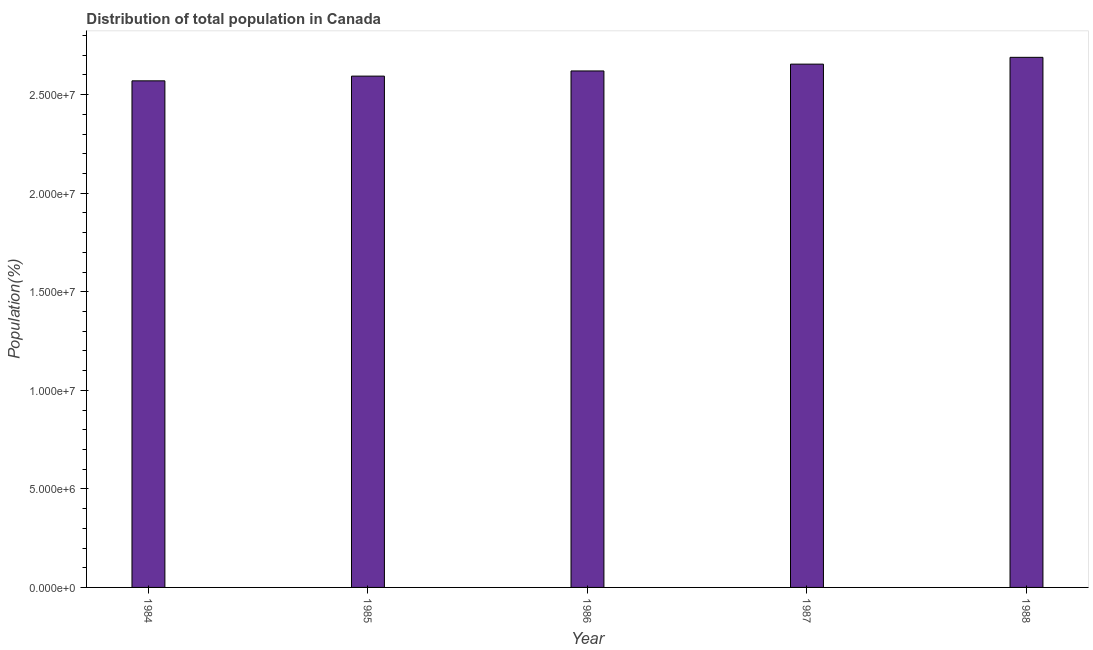Does the graph contain any zero values?
Provide a short and direct response. No. What is the title of the graph?
Your answer should be compact. Distribution of total population in Canada . What is the label or title of the Y-axis?
Give a very brief answer. Population(%). What is the population in 1987?
Provide a succinct answer. 2.66e+07. Across all years, what is the maximum population?
Your answer should be compact. 2.69e+07. Across all years, what is the minimum population?
Give a very brief answer. 2.57e+07. In which year was the population maximum?
Provide a short and direct response. 1988. What is the sum of the population?
Provide a short and direct response. 1.31e+08. What is the difference between the population in 1986 and 1987?
Offer a very short reply. -3.46e+05. What is the average population per year?
Provide a succinct answer. 2.63e+07. What is the median population?
Give a very brief answer. 2.62e+07. What is the ratio of the population in 1987 to that in 1988?
Provide a short and direct response. 0.99. Is the difference between the population in 1986 and 1987 greater than the difference between any two years?
Offer a terse response. No. What is the difference between the highest and the second highest population?
Your response must be concise. 3.45e+05. What is the difference between the highest and the lowest population?
Make the answer very short. 1.19e+06. In how many years, is the population greater than the average population taken over all years?
Offer a very short reply. 2. Are all the bars in the graph horizontal?
Offer a very short reply. No. How many years are there in the graph?
Your response must be concise. 5. Are the values on the major ticks of Y-axis written in scientific E-notation?
Offer a very short reply. Yes. What is the Population(%) in 1984?
Your answer should be compact. 2.57e+07. What is the Population(%) of 1985?
Keep it short and to the point. 2.59e+07. What is the Population(%) of 1986?
Provide a short and direct response. 2.62e+07. What is the Population(%) of 1987?
Ensure brevity in your answer.  2.66e+07. What is the Population(%) of 1988?
Offer a very short reply. 2.69e+07. What is the difference between the Population(%) in 1984 and 1986?
Give a very brief answer. -5.02e+05. What is the difference between the Population(%) in 1984 and 1987?
Your answer should be compact. -8.48e+05. What is the difference between the Population(%) in 1984 and 1988?
Make the answer very short. -1.19e+06. What is the difference between the Population(%) in 1985 and 1986?
Provide a succinct answer. -2.62e+05. What is the difference between the Population(%) in 1985 and 1987?
Make the answer very short. -6.08e+05. What is the difference between the Population(%) in 1985 and 1988?
Make the answer very short. -9.53e+05. What is the difference between the Population(%) in 1986 and 1987?
Ensure brevity in your answer.  -3.46e+05. What is the difference between the Population(%) in 1986 and 1988?
Offer a terse response. -6.91e+05. What is the difference between the Population(%) in 1987 and 1988?
Ensure brevity in your answer.  -3.45e+05. What is the ratio of the Population(%) in 1984 to that in 1985?
Offer a terse response. 0.99. What is the ratio of the Population(%) in 1984 to that in 1986?
Give a very brief answer. 0.98. What is the ratio of the Population(%) in 1984 to that in 1987?
Your response must be concise. 0.97. What is the ratio of the Population(%) in 1984 to that in 1988?
Offer a terse response. 0.96. What is the ratio of the Population(%) in 1987 to that in 1988?
Provide a short and direct response. 0.99. 